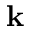<formula> <loc_0><loc_0><loc_500><loc_500>k</formula> 